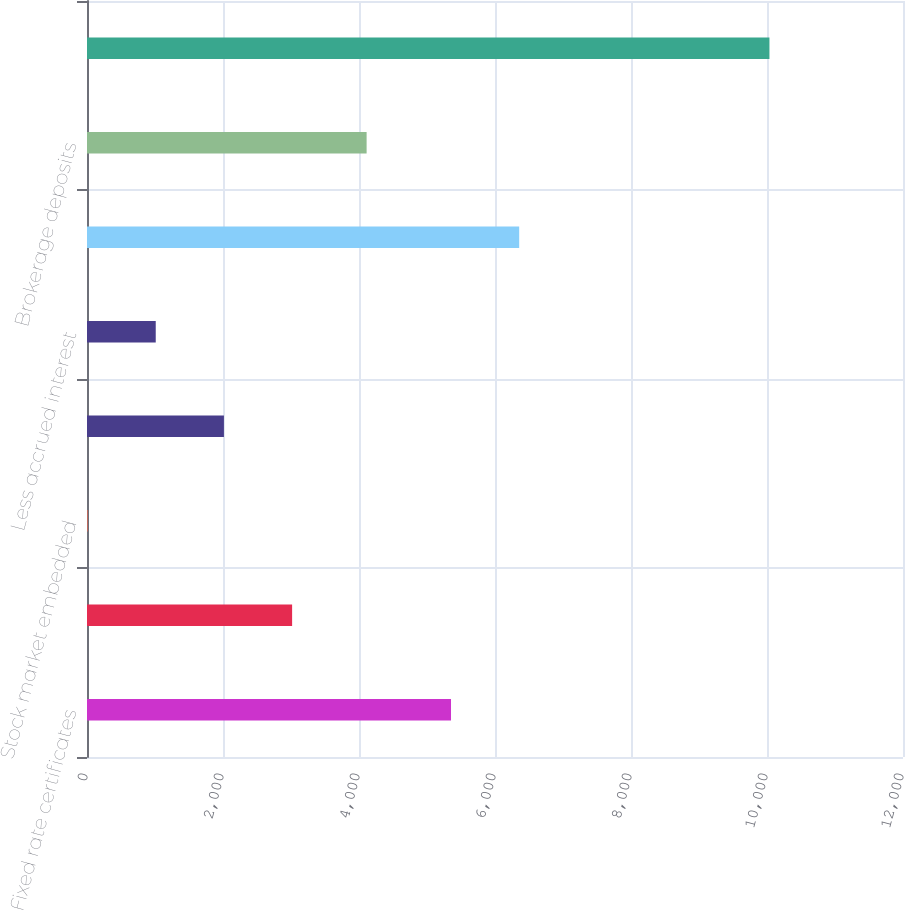<chart> <loc_0><loc_0><loc_500><loc_500><bar_chart><fcel>Fixed rate certificates<fcel>Stock market certificates<fcel>Stock market embedded<fcel>Other<fcel>Less accrued interest<fcel>Total investment certificate<fcel>Brokerage deposits<fcel>Total<nl><fcel>5353<fcel>3016.4<fcel>8<fcel>2013.6<fcel>1010.8<fcel>6355.8<fcel>4112<fcel>10036<nl></chart> 